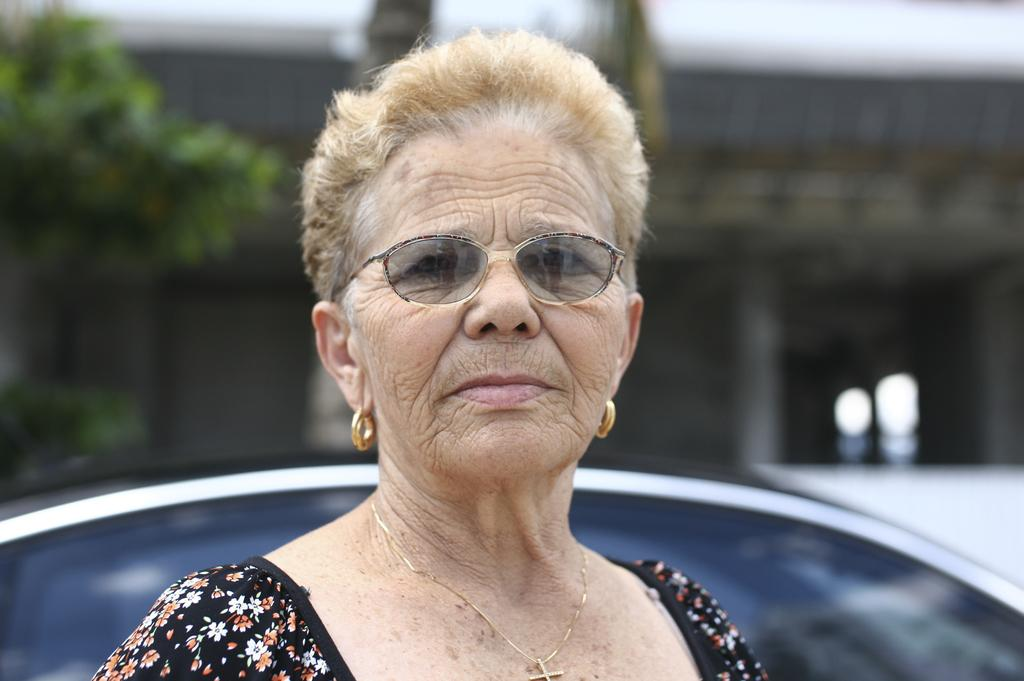What is the main subject in the front of the image? There is a car in the front of the image. Can you describe the woman in the image? The woman in the image is wearing a black dress. What can be seen in the background of the image? There are buildings and trees in the background of the image. How is the background of the image depicted? The background is slightly blurred. How many chickens are sitting on the woman's finger in the image? There are no chickens or fingers visible in the image. What type of growth is shown on the car in the image? There is no growth depicted on the car in the image. 